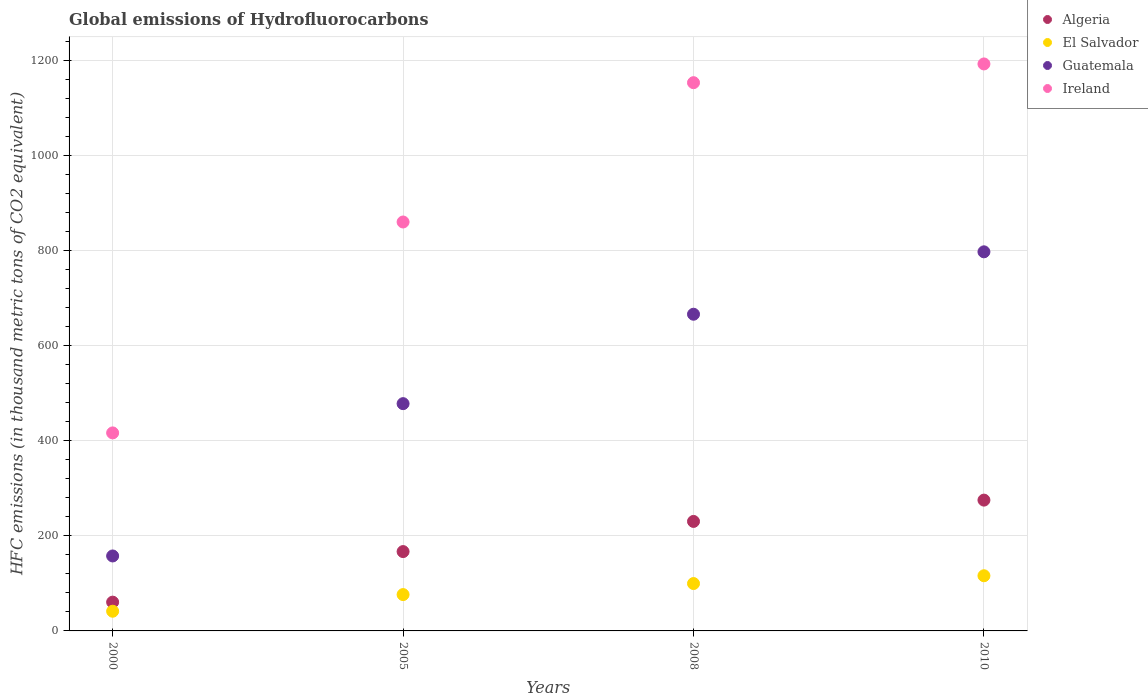How many different coloured dotlines are there?
Ensure brevity in your answer.  4. Is the number of dotlines equal to the number of legend labels?
Provide a succinct answer. Yes. What is the global emissions of Hydrofluorocarbons in Ireland in 2005?
Keep it short and to the point. 859.7. Across all years, what is the maximum global emissions of Hydrofluorocarbons in Algeria?
Provide a succinct answer. 275. Across all years, what is the minimum global emissions of Hydrofluorocarbons in Guatemala?
Ensure brevity in your answer.  157.6. In which year was the global emissions of Hydrofluorocarbons in El Salvador maximum?
Provide a short and direct response. 2010. In which year was the global emissions of Hydrofluorocarbons in Algeria minimum?
Provide a short and direct response. 2000. What is the total global emissions of Hydrofluorocarbons in El Salvador in the graph?
Keep it short and to the point. 333.4. What is the difference between the global emissions of Hydrofluorocarbons in El Salvador in 2008 and that in 2010?
Provide a short and direct response. -16.4. What is the difference between the global emissions of Hydrofluorocarbons in Guatemala in 2000 and the global emissions of Hydrofluorocarbons in Ireland in 2005?
Keep it short and to the point. -702.1. What is the average global emissions of Hydrofluorocarbons in Algeria per year?
Ensure brevity in your answer.  183.12. In the year 2005, what is the difference between the global emissions of Hydrofluorocarbons in Guatemala and global emissions of Hydrofluorocarbons in Algeria?
Your answer should be compact. 311. What is the ratio of the global emissions of Hydrofluorocarbons in El Salvador in 2000 to that in 2010?
Your response must be concise. 0.36. Is the difference between the global emissions of Hydrofluorocarbons in Guatemala in 2000 and 2010 greater than the difference between the global emissions of Hydrofluorocarbons in Algeria in 2000 and 2010?
Your answer should be compact. No. What is the difference between the highest and the second highest global emissions of Hydrofluorocarbons in Guatemala?
Your answer should be very brief. 131.2. What is the difference between the highest and the lowest global emissions of Hydrofluorocarbons in Algeria?
Keep it short and to the point. 214.5. Is the global emissions of Hydrofluorocarbons in Guatemala strictly less than the global emissions of Hydrofluorocarbons in Algeria over the years?
Make the answer very short. No. How many dotlines are there?
Give a very brief answer. 4. How many years are there in the graph?
Provide a succinct answer. 4. What is the difference between two consecutive major ticks on the Y-axis?
Provide a succinct answer. 200. Does the graph contain any zero values?
Offer a very short reply. No. Where does the legend appear in the graph?
Your answer should be compact. Top right. How many legend labels are there?
Keep it short and to the point. 4. What is the title of the graph?
Ensure brevity in your answer.  Global emissions of Hydrofluorocarbons. What is the label or title of the X-axis?
Provide a succinct answer. Years. What is the label or title of the Y-axis?
Your answer should be very brief. HFC emissions (in thousand metric tons of CO2 equivalent). What is the HFC emissions (in thousand metric tons of CO2 equivalent) of Algeria in 2000?
Make the answer very short. 60.5. What is the HFC emissions (in thousand metric tons of CO2 equivalent) of El Salvador in 2000?
Your response must be concise. 41.4. What is the HFC emissions (in thousand metric tons of CO2 equivalent) of Guatemala in 2000?
Your answer should be very brief. 157.6. What is the HFC emissions (in thousand metric tons of CO2 equivalent) of Ireland in 2000?
Your response must be concise. 416.3. What is the HFC emissions (in thousand metric tons of CO2 equivalent) in Algeria in 2005?
Provide a succinct answer. 166.8. What is the HFC emissions (in thousand metric tons of CO2 equivalent) of El Salvador in 2005?
Provide a short and direct response. 76.4. What is the HFC emissions (in thousand metric tons of CO2 equivalent) in Guatemala in 2005?
Ensure brevity in your answer.  477.8. What is the HFC emissions (in thousand metric tons of CO2 equivalent) in Ireland in 2005?
Offer a terse response. 859.7. What is the HFC emissions (in thousand metric tons of CO2 equivalent) in Algeria in 2008?
Make the answer very short. 230.2. What is the HFC emissions (in thousand metric tons of CO2 equivalent) of El Salvador in 2008?
Your answer should be compact. 99.6. What is the HFC emissions (in thousand metric tons of CO2 equivalent) in Guatemala in 2008?
Offer a very short reply. 665.8. What is the HFC emissions (in thousand metric tons of CO2 equivalent) in Ireland in 2008?
Make the answer very short. 1152.6. What is the HFC emissions (in thousand metric tons of CO2 equivalent) of Algeria in 2010?
Your response must be concise. 275. What is the HFC emissions (in thousand metric tons of CO2 equivalent) in El Salvador in 2010?
Your response must be concise. 116. What is the HFC emissions (in thousand metric tons of CO2 equivalent) of Guatemala in 2010?
Give a very brief answer. 797. What is the HFC emissions (in thousand metric tons of CO2 equivalent) of Ireland in 2010?
Your answer should be very brief. 1192. Across all years, what is the maximum HFC emissions (in thousand metric tons of CO2 equivalent) of Algeria?
Give a very brief answer. 275. Across all years, what is the maximum HFC emissions (in thousand metric tons of CO2 equivalent) in El Salvador?
Provide a succinct answer. 116. Across all years, what is the maximum HFC emissions (in thousand metric tons of CO2 equivalent) in Guatemala?
Provide a succinct answer. 797. Across all years, what is the maximum HFC emissions (in thousand metric tons of CO2 equivalent) in Ireland?
Provide a succinct answer. 1192. Across all years, what is the minimum HFC emissions (in thousand metric tons of CO2 equivalent) of Algeria?
Offer a terse response. 60.5. Across all years, what is the minimum HFC emissions (in thousand metric tons of CO2 equivalent) in El Salvador?
Your answer should be compact. 41.4. Across all years, what is the minimum HFC emissions (in thousand metric tons of CO2 equivalent) of Guatemala?
Provide a short and direct response. 157.6. Across all years, what is the minimum HFC emissions (in thousand metric tons of CO2 equivalent) in Ireland?
Ensure brevity in your answer.  416.3. What is the total HFC emissions (in thousand metric tons of CO2 equivalent) of Algeria in the graph?
Offer a very short reply. 732.5. What is the total HFC emissions (in thousand metric tons of CO2 equivalent) in El Salvador in the graph?
Your answer should be very brief. 333.4. What is the total HFC emissions (in thousand metric tons of CO2 equivalent) of Guatemala in the graph?
Your answer should be very brief. 2098.2. What is the total HFC emissions (in thousand metric tons of CO2 equivalent) in Ireland in the graph?
Your answer should be very brief. 3620.6. What is the difference between the HFC emissions (in thousand metric tons of CO2 equivalent) in Algeria in 2000 and that in 2005?
Your response must be concise. -106.3. What is the difference between the HFC emissions (in thousand metric tons of CO2 equivalent) of El Salvador in 2000 and that in 2005?
Offer a terse response. -35. What is the difference between the HFC emissions (in thousand metric tons of CO2 equivalent) of Guatemala in 2000 and that in 2005?
Provide a short and direct response. -320.2. What is the difference between the HFC emissions (in thousand metric tons of CO2 equivalent) in Ireland in 2000 and that in 2005?
Offer a terse response. -443.4. What is the difference between the HFC emissions (in thousand metric tons of CO2 equivalent) in Algeria in 2000 and that in 2008?
Your answer should be compact. -169.7. What is the difference between the HFC emissions (in thousand metric tons of CO2 equivalent) of El Salvador in 2000 and that in 2008?
Your answer should be very brief. -58.2. What is the difference between the HFC emissions (in thousand metric tons of CO2 equivalent) in Guatemala in 2000 and that in 2008?
Ensure brevity in your answer.  -508.2. What is the difference between the HFC emissions (in thousand metric tons of CO2 equivalent) in Ireland in 2000 and that in 2008?
Keep it short and to the point. -736.3. What is the difference between the HFC emissions (in thousand metric tons of CO2 equivalent) of Algeria in 2000 and that in 2010?
Ensure brevity in your answer.  -214.5. What is the difference between the HFC emissions (in thousand metric tons of CO2 equivalent) in El Salvador in 2000 and that in 2010?
Offer a very short reply. -74.6. What is the difference between the HFC emissions (in thousand metric tons of CO2 equivalent) in Guatemala in 2000 and that in 2010?
Keep it short and to the point. -639.4. What is the difference between the HFC emissions (in thousand metric tons of CO2 equivalent) of Ireland in 2000 and that in 2010?
Ensure brevity in your answer.  -775.7. What is the difference between the HFC emissions (in thousand metric tons of CO2 equivalent) of Algeria in 2005 and that in 2008?
Your response must be concise. -63.4. What is the difference between the HFC emissions (in thousand metric tons of CO2 equivalent) of El Salvador in 2005 and that in 2008?
Provide a succinct answer. -23.2. What is the difference between the HFC emissions (in thousand metric tons of CO2 equivalent) of Guatemala in 2005 and that in 2008?
Provide a succinct answer. -188. What is the difference between the HFC emissions (in thousand metric tons of CO2 equivalent) in Ireland in 2005 and that in 2008?
Your response must be concise. -292.9. What is the difference between the HFC emissions (in thousand metric tons of CO2 equivalent) of Algeria in 2005 and that in 2010?
Give a very brief answer. -108.2. What is the difference between the HFC emissions (in thousand metric tons of CO2 equivalent) of El Salvador in 2005 and that in 2010?
Offer a terse response. -39.6. What is the difference between the HFC emissions (in thousand metric tons of CO2 equivalent) of Guatemala in 2005 and that in 2010?
Your answer should be very brief. -319.2. What is the difference between the HFC emissions (in thousand metric tons of CO2 equivalent) of Ireland in 2005 and that in 2010?
Make the answer very short. -332.3. What is the difference between the HFC emissions (in thousand metric tons of CO2 equivalent) of Algeria in 2008 and that in 2010?
Your answer should be compact. -44.8. What is the difference between the HFC emissions (in thousand metric tons of CO2 equivalent) of El Salvador in 2008 and that in 2010?
Provide a succinct answer. -16.4. What is the difference between the HFC emissions (in thousand metric tons of CO2 equivalent) in Guatemala in 2008 and that in 2010?
Your answer should be compact. -131.2. What is the difference between the HFC emissions (in thousand metric tons of CO2 equivalent) of Ireland in 2008 and that in 2010?
Provide a succinct answer. -39.4. What is the difference between the HFC emissions (in thousand metric tons of CO2 equivalent) of Algeria in 2000 and the HFC emissions (in thousand metric tons of CO2 equivalent) of El Salvador in 2005?
Offer a terse response. -15.9. What is the difference between the HFC emissions (in thousand metric tons of CO2 equivalent) in Algeria in 2000 and the HFC emissions (in thousand metric tons of CO2 equivalent) in Guatemala in 2005?
Keep it short and to the point. -417.3. What is the difference between the HFC emissions (in thousand metric tons of CO2 equivalent) in Algeria in 2000 and the HFC emissions (in thousand metric tons of CO2 equivalent) in Ireland in 2005?
Ensure brevity in your answer.  -799.2. What is the difference between the HFC emissions (in thousand metric tons of CO2 equivalent) of El Salvador in 2000 and the HFC emissions (in thousand metric tons of CO2 equivalent) of Guatemala in 2005?
Your answer should be compact. -436.4. What is the difference between the HFC emissions (in thousand metric tons of CO2 equivalent) in El Salvador in 2000 and the HFC emissions (in thousand metric tons of CO2 equivalent) in Ireland in 2005?
Provide a succinct answer. -818.3. What is the difference between the HFC emissions (in thousand metric tons of CO2 equivalent) of Guatemala in 2000 and the HFC emissions (in thousand metric tons of CO2 equivalent) of Ireland in 2005?
Your answer should be compact. -702.1. What is the difference between the HFC emissions (in thousand metric tons of CO2 equivalent) in Algeria in 2000 and the HFC emissions (in thousand metric tons of CO2 equivalent) in El Salvador in 2008?
Your answer should be compact. -39.1. What is the difference between the HFC emissions (in thousand metric tons of CO2 equivalent) in Algeria in 2000 and the HFC emissions (in thousand metric tons of CO2 equivalent) in Guatemala in 2008?
Your response must be concise. -605.3. What is the difference between the HFC emissions (in thousand metric tons of CO2 equivalent) of Algeria in 2000 and the HFC emissions (in thousand metric tons of CO2 equivalent) of Ireland in 2008?
Your response must be concise. -1092.1. What is the difference between the HFC emissions (in thousand metric tons of CO2 equivalent) of El Salvador in 2000 and the HFC emissions (in thousand metric tons of CO2 equivalent) of Guatemala in 2008?
Ensure brevity in your answer.  -624.4. What is the difference between the HFC emissions (in thousand metric tons of CO2 equivalent) of El Salvador in 2000 and the HFC emissions (in thousand metric tons of CO2 equivalent) of Ireland in 2008?
Your response must be concise. -1111.2. What is the difference between the HFC emissions (in thousand metric tons of CO2 equivalent) in Guatemala in 2000 and the HFC emissions (in thousand metric tons of CO2 equivalent) in Ireland in 2008?
Your answer should be very brief. -995. What is the difference between the HFC emissions (in thousand metric tons of CO2 equivalent) in Algeria in 2000 and the HFC emissions (in thousand metric tons of CO2 equivalent) in El Salvador in 2010?
Provide a succinct answer. -55.5. What is the difference between the HFC emissions (in thousand metric tons of CO2 equivalent) of Algeria in 2000 and the HFC emissions (in thousand metric tons of CO2 equivalent) of Guatemala in 2010?
Ensure brevity in your answer.  -736.5. What is the difference between the HFC emissions (in thousand metric tons of CO2 equivalent) of Algeria in 2000 and the HFC emissions (in thousand metric tons of CO2 equivalent) of Ireland in 2010?
Give a very brief answer. -1131.5. What is the difference between the HFC emissions (in thousand metric tons of CO2 equivalent) in El Salvador in 2000 and the HFC emissions (in thousand metric tons of CO2 equivalent) in Guatemala in 2010?
Make the answer very short. -755.6. What is the difference between the HFC emissions (in thousand metric tons of CO2 equivalent) in El Salvador in 2000 and the HFC emissions (in thousand metric tons of CO2 equivalent) in Ireland in 2010?
Your response must be concise. -1150.6. What is the difference between the HFC emissions (in thousand metric tons of CO2 equivalent) of Guatemala in 2000 and the HFC emissions (in thousand metric tons of CO2 equivalent) of Ireland in 2010?
Your answer should be compact. -1034.4. What is the difference between the HFC emissions (in thousand metric tons of CO2 equivalent) of Algeria in 2005 and the HFC emissions (in thousand metric tons of CO2 equivalent) of El Salvador in 2008?
Ensure brevity in your answer.  67.2. What is the difference between the HFC emissions (in thousand metric tons of CO2 equivalent) of Algeria in 2005 and the HFC emissions (in thousand metric tons of CO2 equivalent) of Guatemala in 2008?
Your response must be concise. -499. What is the difference between the HFC emissions (in thousand metric tons of CO2 equivalent) in Algeria in 2005 and the HFC emissions (in thousand metric tons of CO2 equivalent) in Ireland in 2008?
Make the answer very short. -985.8. What is the difference between the HFC emissions (in thousand metric tons of CO2 equivalent) in El Salvador in 2005 and the HFC emissions (in thousand metric tons of CO2 equivalent) in Guatemala in 2008?
Give a very brief answer. -589.4. What is the difference between the HFC emissions (in thousand metric tons of CO2 equivalent) of El Salvador in 2005 and the HFC emissions (in thousand metric tons of CO2 equivalent) of Ireland in 2008?
Your response must be concise. -1076.2. What is the difference between the HFC emissions (in thousand metric tons of CO2 equivalent) of Guatemala in 2005 and the HFC emissions (in thousand metric tons of CO2 equivalent) of Ireland in 2008?
Offer a very short reply. -674.8. What is the difference between the HFC emissions (in thousand metric tons of CO2 equivalent) of Algeria in 2005 and the HFC emissions (in thousand metric tons of CO2 equivalent) of El Salvador in 2010?
Make the answer very short. 50.8. What is the difference between the HFC emissions (in thousand metric tons of CO2 equivalent) in Algeria in 2005 and the HFC emissions (in thousand metric tons of CO2 equivalent) in Guatemala in 2010?
Make the answer very short. -630.2. What is the difference between the HFC emissions (in thousand metric tons of CO2 equivalent) of Algeria in 2005 and the HFC emissions (in thousand metric tons of CO2 equivalent) of Ireland in 2010?
Make the answer very short. -1025.2. What is the difference between the HFC emissions (in thousand metric tons of CO2 equivalent) in El Salvador in 2005 and the HFC emissions (in thousand metric tons of CO2 equivalent) in Guatemala in 2010?
Ensure brevity in your answer.  -720.6. What is the difference between the HFC emissions (in thousand metric tons of CO2 equivalent) of El Salvador in 2005 and the HFC emissions (in thousand metric tons of CO2 equivalent) of Ireland in 2010?
Give a very brief answer. -1115.6. What is the difference between the HFC emissions (in thousand metric tons of CO2 equivalent) in Guatemala in 2005 and the HFC emissions (in thousand metric tons of CO2 equivalent) in Ireland in 2010?
Make the answer very short. -714.2. What is the difference between the HFC emissions (in thousand metric tons of CO2 equivalent) of Algeria in 2008 and the HFC emissions (in thousand metric tons of CO2 equivalent) of El Salvador in 2010?
Make the answer very short. 114.2. What is the difference between the HFC emissions (in thousand metric tons of CO2 equivalent) in Algeria in 2008 and the HFC emissions (in thousand metric tons of CO2 equivalent) in Guatemala in 2010?
Provide a succinct answer. -566.8. What is the difference between the HFC emissions (in thousand metric tons of CO2 equivalent) of Algeria in 2008 and the HFC emissions (in thousand metric tons of CO2 equivalent) of Ireland in 2010?
Provide a short and direct response. -961.8. What is the difference between the HFC emissions (in thousand metric tons of CO2 equivalent) of El Salvador in 2008 and the HFC emissions (in thousand metric tons of CO2 equivalent) of Guatemala in 2010?
Your answer should be very brief. -697.4. What is the difference between the HFC emissions (in thousand metric tons of CO2 equivalent) in El Salvador in 2008 and the HFC emissions (in thousand metric tons of CO2 equivalent) in Ireland in 2010?
Make the answer very short. -1092.4. What is the difference between the HFC emissions (in thousand metric tons of CO2 equivalent) of Guatemala in 2008 and the HFC emissions (in thousand metric tons of CO2 equivalent) of Ireland in 2010?
Offer a terse response. -526.2. What is the average HFC emissions (in thousand metric tons of CO2 equivalent) of Algeria per year?
Give a very brief answer. 183.12. What is the average HFC emissions (in thousand metric tons of CO2 equivalent) in El Salvador per year?
Your answer should be compact. 83.35. What is the average HFC emissions (in thousand metric tons of CO2 equivalent) in Guatemala per year?
Offer a very short reply. 524.55. What is the average HFC emissions (in thousand metric tons of CO2 equivalent) of Ireland per year?
Give a very brief answer. 905.15. In the year 2000, what is the difference between the HFC emissions (in thousand metric tons of CO2 equivalent) in Algeria and HFC emissions (in thousand metric tons of CO2 equivalent) in El Salvador?
Provide a succinct answer. 19.1. In the year 2000, what is the difference between the HFC emissions (in thousand metric tons of CO2 equivalent) in Algeria and HFC emissions (in thousand metric tons of CO2 equivalent) in Guatemala?
Provide a succinct answer. -97.1. In the year 2000, what is the difference between the HFC emissions (in thousand metric tons of CO2 equivalent) of Algeria and HFC emissions (in thousand metric tons of CO2 equivalent) of Ireland?
Your answer should be very brief. -355.8. In the year 2000, what is the difference between the HFC emissions (in thousand metric tons of CO2 equivalent) in El Salvador and HFC emissions (in thousand metric tons of CO2 equivalent) in Guatemala?
Ensure brevity in your answer.  -116.2. In the year 2000, what is the difference between the HFC emissions (in thousand metric tons of CO2 equivalent) in El Salvador and HFC emissions (in thousand metric tons of CO2 equivalent) in Ireland?
Your response must be concise. -374.9. In the year 2000, what is the difference between the HFC emissions (in thousand metric tons of CO2 equivalent) in Guatemala and HFC emissions (in thousand metric tons of CO2 equivalent) in Ireland?
Your answer should be very brief. -258.7. In the year 2005, what is the difference between the HFC emissions (in thousand metric tons of CO2 equivalent) in Algeria and HFC emissions (in thousand metric tons of CO2 equivalent) in El Salvador?
Provide a short and direct response. 90.4. In the year 2005, what is the difference between the HFC emissions (in thousand metric tons of CO2 equivalent) of Algeria and HFC emissions (in thousand metric tons of CO2 equivalent) of Guatemala?
Make the answer very short. -311. In the year 2005, what is the difference between the HFC emissions (in thousand metric tons of CO2 equivalent) of Algeria and HFC emissions (in thousand metric tons of CO2 equivalent) of Ireland?
Offer a very short reply. -692.9. In the year 2005, what is the difference between the HFC emissions (in thousand metric tons of CO2 equivalent) in El Salvador and HFC emissions (in thousand metric tons of CO2 equivalent) in Guatemala?
Offer a very short reply. -401.4. In the year 2005, what is the difference between the HFC emissions (in thousand metric tons of CO2 equivalent) of El Salvador and HFC emissions (in thousand metric tons of CO2 equivalent) of Ireland?
Your answer should be compact. -783.3. In the year 2005, what is the difference between the HFC emissions (in thousand metric tons of CO2 equivalent) in Guatemala and HFC emissions (in thousand metric tons of CO2 equivalent) in Ireland?
Keep it short and to the point. -381.9. In the year 2008, what is the difference between the HFC emissions (in thousand metric tons of CO2 equivalent) of Algeria and HFC emissions (in thousand metric tons of CO2 equivalent) of El Salvador?
Offer a very short reply. 130.6. In the year 2008, what is the difference between the HFC emissions (in thousand metric tons of CO2 equivalent) in Algeria and HFC emissions (in thousand metric tons of CO2 equivalent) in Guatemala?
Provide a succinct answer. -435.6. In the year 2008, what is the difference between the HFC emissions (in thousand metric tons of CO2 equivalent) in Algeria and HFC emissions (in thousand metric tons of CO2 equivalent) in Ireland?
Provide a short and direct response. -922.4. In the year 2008, what is the difference between the HFC emissions (in thousand metric tons of CO2 equivalent) of El Salvador and HFC emissions (in thousand metric tons of CO2 equivalent) of Guatemala?
Provide a succinct answer. -566.2. In the year 2008, what is the difference between the HFC emissions (in thousand metric tons of CO2 equivalent) in El Salvador and HFC emissions (in thousand metric tons of CO2 equivalent) in Ireland?
Make the answer very short. -1053. In the year 2008, what is the difference between the HFC emissions (in thousand metric tons of CO2 equivalent) of Guatemala and HFC emissions (in thousand metric tons of CO2 equivalent) of Ireland?
Your response must be concise. -486.8. In the year 2010, what is the difference between the HFC emissions (in thousand metric tons of CO2 equivalent) of Algeria and HFC emissions (in thousand metric tons of CO2 equivalent) of El Salvador?
Your response must be concise. 159. In the year 2010, what is the difference between the HFC emissions (in thousand metric tons of CO2 equivalent) in Algeria and HFC emissions (in thousand metric tons of CO2 equivalent) in Guatemala?
Offer a terse response. -522. In the year 2010, what is the difference between the HFC emissions (in thousand metric tons of CO2 equivalent) of Algeria and HFC emissions (in thousand metric tons of CO2 equivalent) of Ireland?
Make the answer very short. -917. In the year 2010, what is the difference between the HFC emissions (in thousand metric tons of CO2 equivalent) of El Salvador and HFC emissions (in thousand metric tons of CO2 equivalent) of Guatemala?
Give a very brief answer. -681. In the year 2010, what is the difference between the HFC emissions (in thousand metric tons of CO2 equivalent) in El Salvador and HFC emissions (in thousand metric tons of CO2 equivalent) in Ireland?
Your response must be concise. -1076. In the year 2010, what is the difference between the HFC emissions (in thousand metric tons of CO2 equivalent) in Guatemala and HFC emissions (in thousand metric tons of CO2 equivalent) in Ireland?
Your response must be concise. -395. What is the ratio of the HFC emissions (in thousand metric tons of CO2 equivalent) in Algeria in 2000 to that in 2005?
Make the answer very short. 0.36. What is the ratio of the HFC emissions (in thousand metric tons of CO2 equivalent) of El Salvador in 2000 to that in 2005?
Offer a terse response. 0.54. What is the ratio of the HFC emissions (in thousand metric tons of CO2 equivalent) of Guatemala in 2000 to that in 2005?
Ensure brevity in your answer.  0.33. What is the ratio of the HFC emissions (in thousand metric tons of CO2 equivalent) in Ireland in 2000 to that in 2005?
Give a very brief answer. 0.48. What is the ratio of the HFC emissions (in thousand metric tons of CO2 equivalent) of Algeria in 2000 to that in 2008?
Ensure brevity in your answer.  0.26. What is the ratio of the HFC emissions (in thousand metric tons of CO2 equivalent) in El Salvador in 2000 to that in 2008?
Provide a short and direct response. 0.42. What is the ratio of the HFC emissions (in thousand metric tons of CO2 equivalent) in Guatemala in 2000 to that in 2008?
Provide a short and direct response. 0.24. What is the ratio of the HFC emissions (in thousand metric tons of CO2 equivalent) in Ireland in 2000 to that in 2008?
Ensure brevity in your answer.  0.36. What is the ratio of the HFC emissions (in thousand metric tons of CO2 equivalent) in Algeria in 2000 to that in 2010?
Your answer should be compact. 0.22. What is the ratio of the HFC emissions (in thousand metric tons of CO2 equivalent) of El Salvador in 2000 to that in 2010?
Give a very brief answer. 0.36. What is the ratio of the HFC emissions (in thousand metric tons of CO2 equivalent) in Guatemala in 2000 to that in 2010?
Your response must be concise. 0.2. What is the ratio of the HFC emissions (in thousand metric tons of CO2 equivalent) in Ireland in 2000 to that in 2010?
Offer a terse response. 0.35. What is the ratio of the HFC emissions (in thousand metric tons of CO2 equivalent) in Algeria in 2005 to that in 2008?
Keep it short and to the point. 0.72. What is the ratio of the HFC emissions (in thousand metric tons of CO2 equivalent) of El Salvador in 2005 to that in 2008?
Make the answer very short. 0.77. What is the ratio of the HFC emissions (in thousand metric tons of CO2 equivalent) in Guatemala in 2005 to that in 2008?
Provide a short and direct response. 0.72. What is the ratio of the HFC emissions (in thousand metric tons of CO2 equivalent) in Ireland in 2005 to that in 2008?
Offer a very short reply. 0.75. What is the ratio of the HFC emissions (in thousand metric tons of CO2 equivalent) of Algeria in 2005 to that in 2010?
Offer a terse response. 0.61. What is the ratio of the HFC emissions (in thousand metric tons of CO2 equivalent) of El Salvador in 2005 to that in 2010?
Your answer should be compact. 0.66. What is the ratio of the HFC emissions (in thousand metric tons of CO2 equivalent) in Guatemala in 2005 to that in 2010?
Your answer should be compact. 0.6. What is the ratio of the HFC emissions (in thousand metric tons of CO2 equivalent) in Ireland in 2005 to that in 2010?
Your answer should be very brief. 0.72. What is the ratio of the HFC emissions (in thousand metric tons of CO2 equivalent) of Algeria in 2008 to that in 2010?
Your response must be concise. 0.84. What is the ratio of the HFC emissions (in thousand metric tons of CO2 equivalent) of El Salvador in 2008 to that in 2010?
Your response must be concise. 0.86. What is the ratio of the HFC emissions (in thousand metric tons of CO2 equivalent) of Guatemala in 2008 to that in 2010?
Provide a succinct answer. 0.84. What is the ratio of the HFC emissions (in thousand metric tons of CO2 equivalent) of Ireland in 2008 to that in 2010?
Your response must be concise. 0.97. What is the difference between the highest and the second highest HFC emissions (in thousand metric tons of CO2 equivalent) of Algeria?
Give a very brief answer. 44.8. What is the difference between the highest and the second highest HFC emissions (in thousand metric tons of CO2 equivalent) in Guatemala?
Keep it short and to the point. 131.2. What is the difference between the highest and the second highest HFC emissions (in thousand metric tons of CO2 equivalent) of Ireland?
Make the answer very short. 39.4. What is the difference between the highest and the lowest HFC emissions (in thousand metric tons of CO2 equivalent) of Algeria?
Give a very brief answer. 214.5. What is the difference between the highest and the lowest HFC emissions (in thousand metric tons of CO2 equivalent) in El Salvador?
Provide a short and direct response. 74.6. What is the difference between the highest and the lowest HFC emissions (in thousand metric tons of CO2 equivalent) of Guatemala?
Your answer should be compact. 639.4. What is the difference between the highest and the lowest HFC emissions (in thousand metric tons of CO2 equivalent) of Ireland?
Keep it short and to the point. 775.7. 